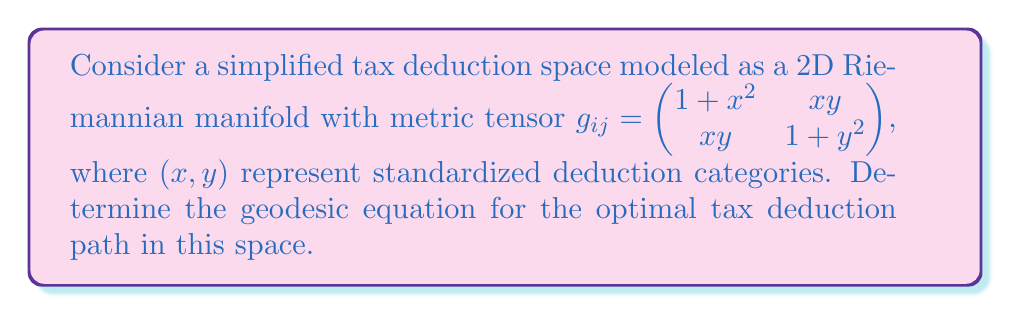Show me your answer to this math problem. To find the geodesic equation, we'll follow these steps:

1) First, we need to calculate the Christoffel symbols $\Gamma^k_{ij}$ using the formula:

   $\Gamma^k_{ij} = \frac{1}{2}g^{kl}(\partial_i g_{jl} + \partial_j g_{il} - \partial_l g_{ij})$

2) Calculate the inverse metric tensor $g^{ij}$:
   
   $g^{ij} = \frac{1}{\det(g_{ij})} \begin{pmatrix} 1+y^2 & -xy \\ -xy & 1+x^2 \end{pmatrix}$

   where $\det(g_{ij}) = (1+x^2)(1+y^2) - x^2y^2 = 1 + x^2 + y^2$

3) Calculate the partial derivatives of $g_{ij}$:

   $\partial_x g_{11} = 2x$, $\partial_x g_{12} = y$, $\partial_x g_{22} = 0$
   $\partial_y g_{11} = 0$, $\partial_y g_{12} = x$, $\partial_y g_{22} = 2y$

4) Now we can calculate the Christoffel symbols. For example:

   $\Gamma^1_{11} = \frac{1}{2}(g^{11}(2x) + g^{12}(y) - g^{11}(2x)) = \frac{xy}{2(1+x^2+y^2)}$

5) After calculating all Christoffel symbols, we can write the geodesic equations:

   $\frac{d^2x}{dt^2} + \Gamma^1_{11}(\frac{dx}{dt})^2 + 2\Gamma^1_{12}\frac{dx}{dt}\frac{dy}{dt} + \Gamma^1_{22}(\frac{dy}{dt})^2 = 0$

   $\frac{d^2y}{dt^2} + \Gamma^2_{11}(\frac{dx}{dt})^2 + 2\Gamma^2_{12}\frac{dx}{dt}\frac{dy}{dt} + \Gamma^2_{22}(\frac{dy}{dt})^2 = 0$

6) Substituting the calculated Christoffel symbols, we get the final geodesic equations:

   $\frac{d^2x}{dt^2} + \frac{xy}{1+x^2+y^2}(\frac{dx}{dt})^2 + \frac{x^2-y^2}{1+x^2+y^2}\frac{dx}{dt}\frac{dy}{dt} - \frac{xy}{1+x^2+y^2}(\frac{dy}{dt})^2 = 0$

   $\frac{d^2y}{dt^2} - \frac{xy}{1+x^2+y^2}(\frac{dx}{dt})^2 + \frac{y^2-x^2}{1+x^2+y^2}\frac{dx}{dt}\frac{dy}{dt} + \frac{xy}{1+x^2+y^2}(\frac{dy}{dt})^2 = 0$

These equations describe the optimal tax deduction paths in our simplified model.
Answer: $$\begin{cases}
\frac{d^2x}{dt^2} + \frac{xy}{1+x^2+y^2}(\frac{dx}{dt})^2 + \frac{x^2-y^2}{1+x^2+y^2}\frac{dx}{dt}\frac{dy}{dt} - \frac{xy}{1+x^2+y^2}(\frac{dy}{dt})^2 = 0 \\
\frac{d^2y}{dt^2} - \frac{xy}{1+x^2+y^2}(\frac{dx}{dt})^2 + \frac{y^2-x^2}{1+x^2+y^2}\frac{dx}{dt}\frac{dy}{dt} + \frac{xy}{1+x^2+y^2}(\frac{dy}{dt})^2 = 0
\end{cases}$$ 